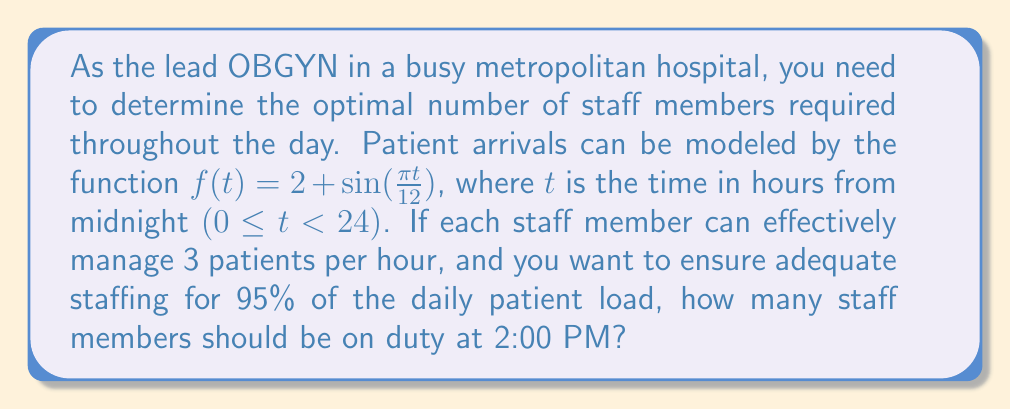Show me your answer to this math problem. 1) First, we need to calculate the total number of patients expected over 24 hours:

   $$\int_0^{24} f(t) dt = \int_0^{24} (2 + \sin(\frac{\pi t}{12})) dt$$

2) Integrate:
   $$= [2t - \frac{12}{\pi} \cos(\frac{\pi t}{12})]_0^{24}$$
   $$= (48 - \frac{12}{\pi} \cos(2\pi)) - (0 - \frac{12}{\pi} \cos(0))$$
   $$= 48 - \frac{12}{\pi} + \frac{12}{\pi} = 48$$

3) The total daily patient load is 48 patients.

4) 95% of 48 is 45.6 patients.

5) To find the number of staff needed at 2:00 PM (t = 14), we evaluate f(14):

   $$f(14) = 2 + \sin(\frac{\pi \cdot 14}{12}) = 2 + \sin(\frac{7\pi}{6}) \approx 2.5$$

6) If each staff member can manage 3 patients per hour, we need:

   $$\frac{2.5}{3} \approx 0.833$$

7) Rounding up to ensure adequate staffing, we need 1 staff member.

8) However, to account for 95% of daily load, we multiply this by 95%:

   $$1 \cdot \frac{45.6}{48} \approx 0.95$$

9) Rounding up again for safety, we get 1 staff member.
Answer: 1 staff member 